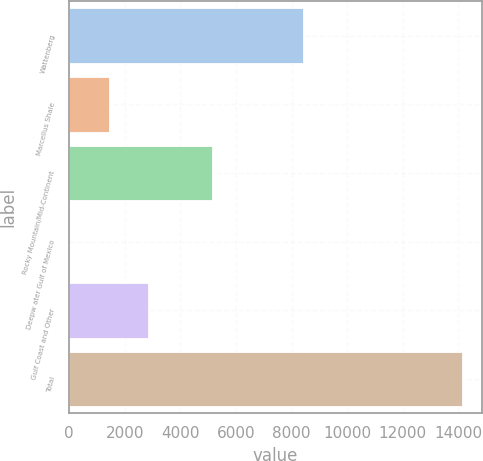Convert chart to OTSL. <chart><loc_0><loc_0><loc_500><loc_500><bar_chart><fcel>Wattenberg<fcel>Marcellus Shale<fcel>Rocky Mountain/Mid-Continent<fcel>Deepw ater Gulf of Mexico<fcel>Gulf Coast and Other<fcel>Total<nl><fcel>8415<fcel>1419.7<fcel>5120<fcel>7<fcel>2832.4<fcel>14134<nl></chart> 